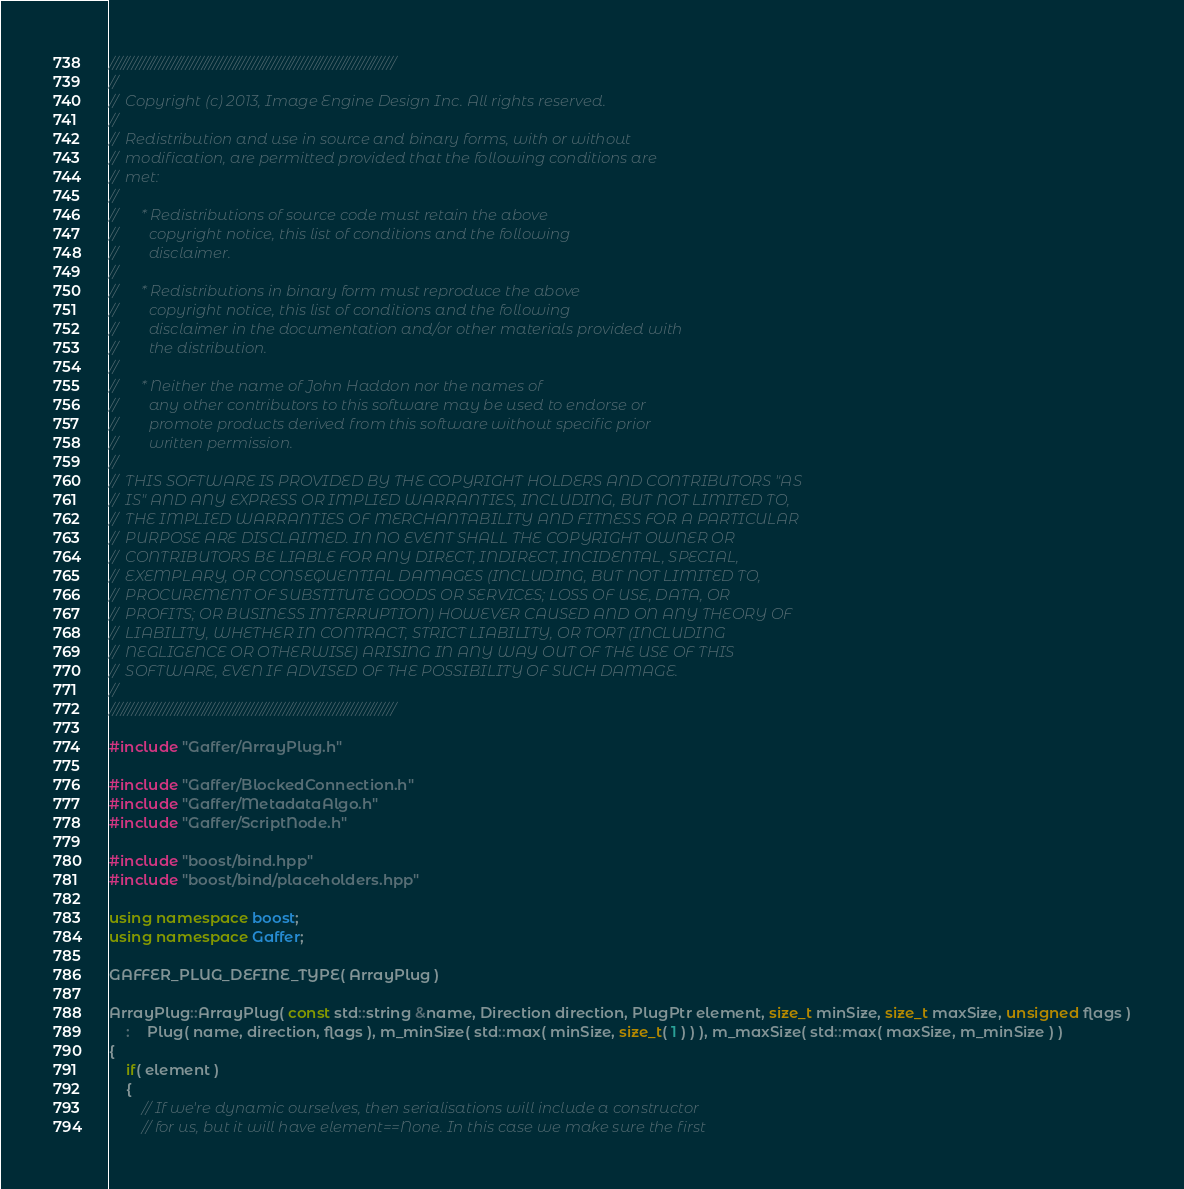Convert code to text. <code><loc_0><loc_0><loc_500><loc_500><_C++_>//////////////////////////////////////////////////////////////////////////
//
//  Copyright (c) 2013, Image Engine Design Inc. All rights reserved.
//
//  Redistribution and use in source and binary forms, with or without
//  modification, are permitted provided that the following conditions are
//  met:
//
//      * Redistributions of source code must retain the above
//        copyright notice, this list of conditions and the following
//        disclaimer.
//
//      * Redistributions in binary form must reproduce the above
//        copyright notice, this list of conditions and the following
//        disclaimer in the documentation and/or other materials provided with
//        the distribution.
//
//      * Neither the name of John Haddon nor the names of
//        any other contributors to this software may be used to endorse or
//        promote products derived from this software without specific prior
//        written permission.
//
//  THIS SOFTWARE IS PROVIDED BY THE COPYRIGHT HOLDERS AND CONTRIBUTORS "AS
//  IS" AND ANY EXPRESS OR IMPLIED WARRANTIES, INCLUDING, BUT NOT LIMITED TO,
//  THE IMPLIED WARRANTIES OF MERCHANTABILITY AND FITNESS FOR A PARTICULAR
//  PURPOSE ARE DISCLAIMED. IN NO EVENT SHALL THE COPYRIGHT OWNER OR
//  CONTRIBUTORS BE LIABLE FOR ANY DIRECT, INDIRECT, INCIDENTAL, SPECIAL,
//  EXEMPLARY, OR CONSEQUENTIAL DAMAGES (INCLUDING, BUT NOT LIMITED TO,
//  PROCUREMENT OF SUBSTITUTE GOODS OR SERVICES; LOSS OF USE, DATA, OR
//  PROFITS; OR BUSINESS INTERRUPTION) HOWEVER CAUSED AND ON ANY THEORY OF
//  LIABILITY, WHETHER IN CONTRACT, STRICT LIABILITY, OR TORT (INCLUDING
//  NEGLIGENCE OR OTHERWISE) ARISING IN ANY WAY OUT OF THE USE OF THIS
//  SOFTWARE, EVEN IF ADVISED OF THE POSSIBILITY OF SUCH DAMAGE.
//
//////////////////////////////////////////////////////////////////////////

#include "Gaffer/ArrayPlug.h"

#include "Gaffer/BlockedConnection.h"
#include "Gaffer/MetadataAlgo.h"
#include "Gaffer/ScriptNode.h"

#include "boost/bind.hpp"
#include "boost/bind/placeholders.hpp"

using namespace boost;
using namespace Gaffer;

GAFFER_PLUG_DEFINE_TYPE( ArrayPlug )

ArrayPlug::ArrayPlug( const std::string &name, Direction direction, PlugPtr element, size_t minSize, size_t maxSize, unsigned flags )
	:	Plug( name, direction, flags ), m_minSize( std::max( minSize, size_t( 1 ) ) ), m_maxSize( std::max( maxSize, m_minSize ) )
{
	if( element )
	{
		// If we're dynamic ourselves, then serialisations will include a constructor
		// for us, but it will have element==None. In this case we make sure the first</code> 